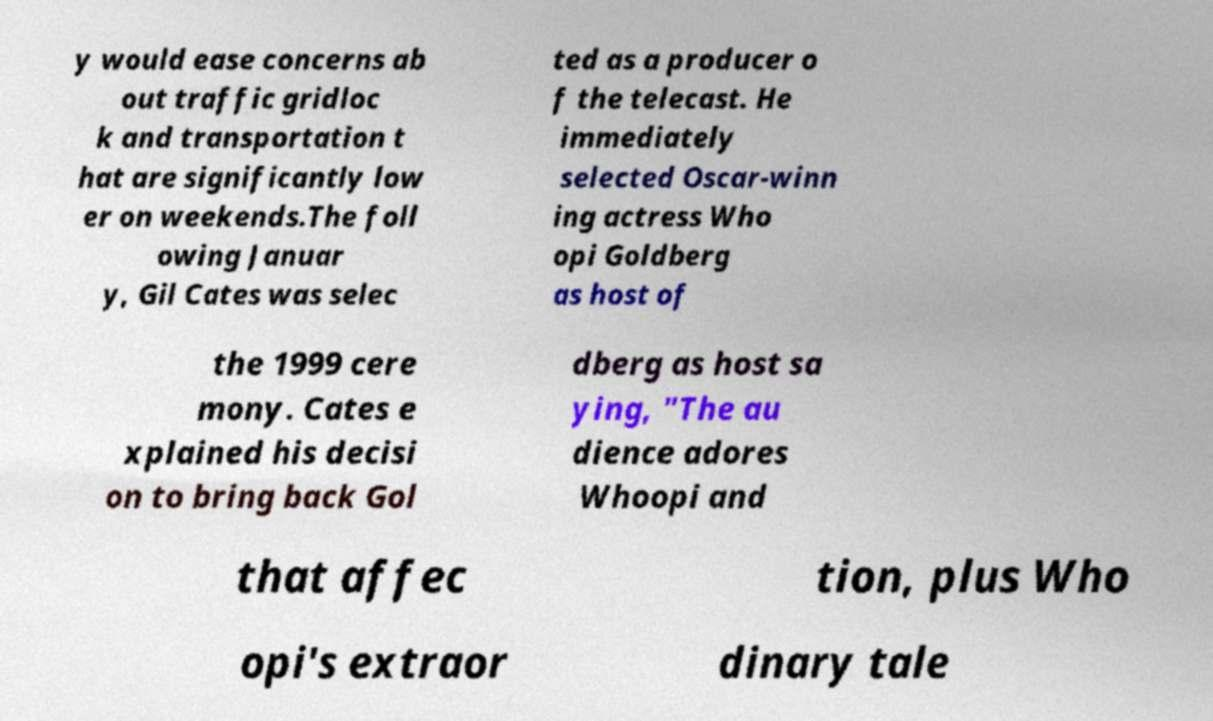Please identify and transcribe the text found in this image. y would ease concerns ab out traffic gridloc k and transportation t hat are significantly low er on weekends.The foll owing Januar y, Gil Cates was selec ted as a producer o f the telecast. He immediately selected Oscar-winn ing actress Who opi Goldberg as host of the 1999 cere mony. Cates e xplained his decisi on to bring back Gol dberg as host sa ying, "The au dience adores Whoopi and that affec tion, plus Who opi's extraor dinary tale 